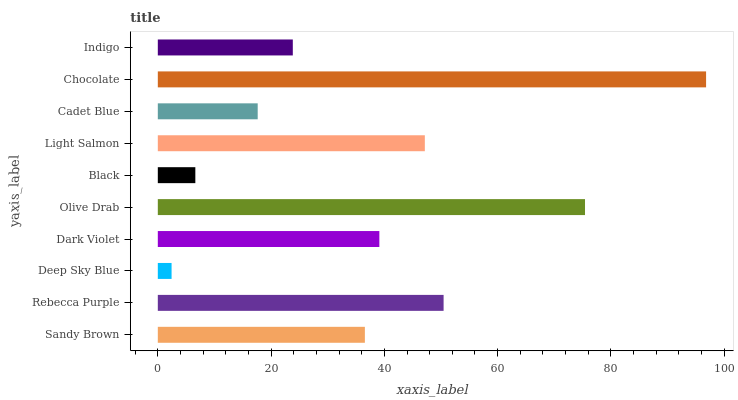Is Deep Sky Blue the minimum?
Answer yes or no. Yes. Is Chocolate the maximum?
Answer yes or no. Yes. Is Rebecca Purple the minimum?
Answer yes or no. No. Is Rebecca Purple the maximum?
Answer yes or no. No. Is Rebecca Purple greater than Sandy Brown?
Answer yes or no. Yes. Is Sandy Brown less than Rebecca Purple?
Answer yes or no. Yes. Is Sandy Brown greater than Rebecca Purple?
Answer yes or no. No. Is Rebecca Purple less than Sandy Brown?
Answer yes or no. No. Is Dark Violet the high median?
Answer yes or no. Yes. Is Sandy Brown the low median?
Answer yes or no. Yes. Is Olive Drab the high median?
Answer yes or no. No. Is Indigo the low median?
Answer yes or no. No. 